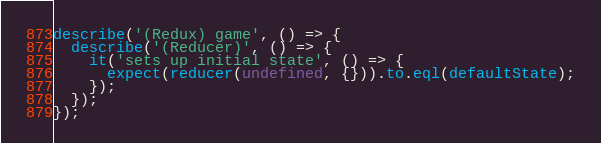<code> <loc_0><loc_0><loc_500><loc_500><_JavaScript_>
describe('(Redux) game', () => {
  describe('(Reducer)', () => {
    it('sets up initial state', () => {
      expect(reducer(undefined, {})).to.eql(defaultState);
    });
  });
});
</code> 